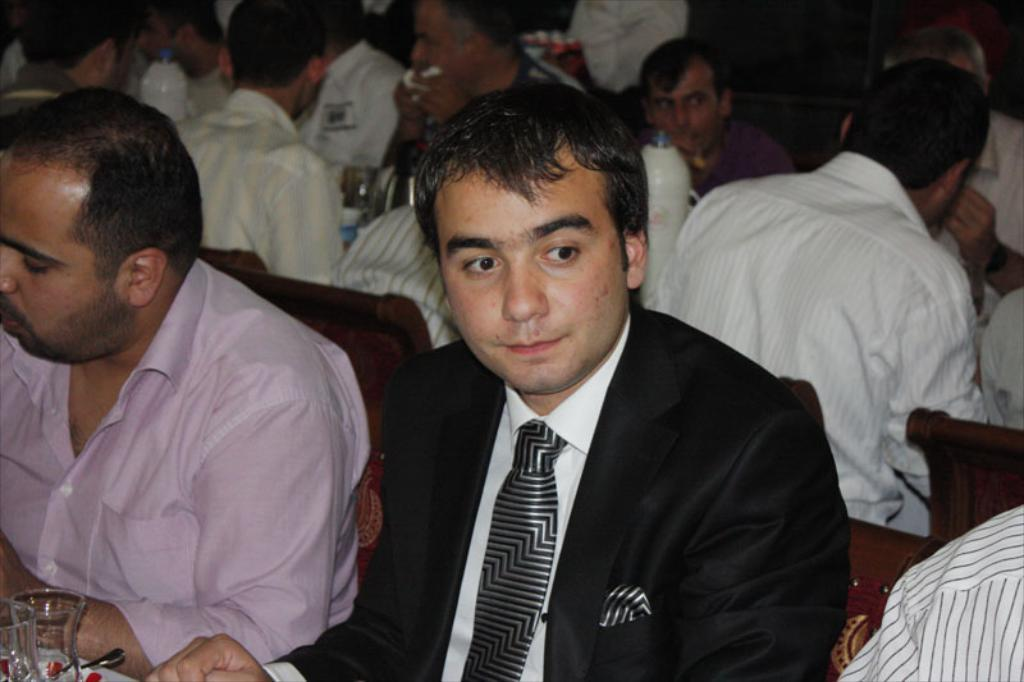What are the people in the image doing? The people in the image are sitting. Where are the people sitting in relation to the table? The people are sitting in front of a table. What can be seen on the table in the image? There are things placed on the table. What is the attire of one person in the image? One person in the image is wearing a suit. What color of paint is being used by the person in the image? There is no paint or painting activity present in the image. What type of toothpaste is being used by the person in the image? There is no toothpaste or brushing activity present in the image. 